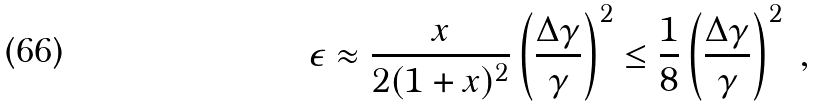<formula> <loc_0><loc_0><loc_500><loc_500>\epsilon \approx \frac { x } { 2 ( 1 + x ) ^ { 2 } } \left ( \frac { \Delta \gamma } { \gamma } \right ) ^ { 2 } \leq \frac { 1 } { 8 } \left ( \frac { \Delta \gamma } { \gamma } \right ) ^ { 2 } \ ,</formula> 